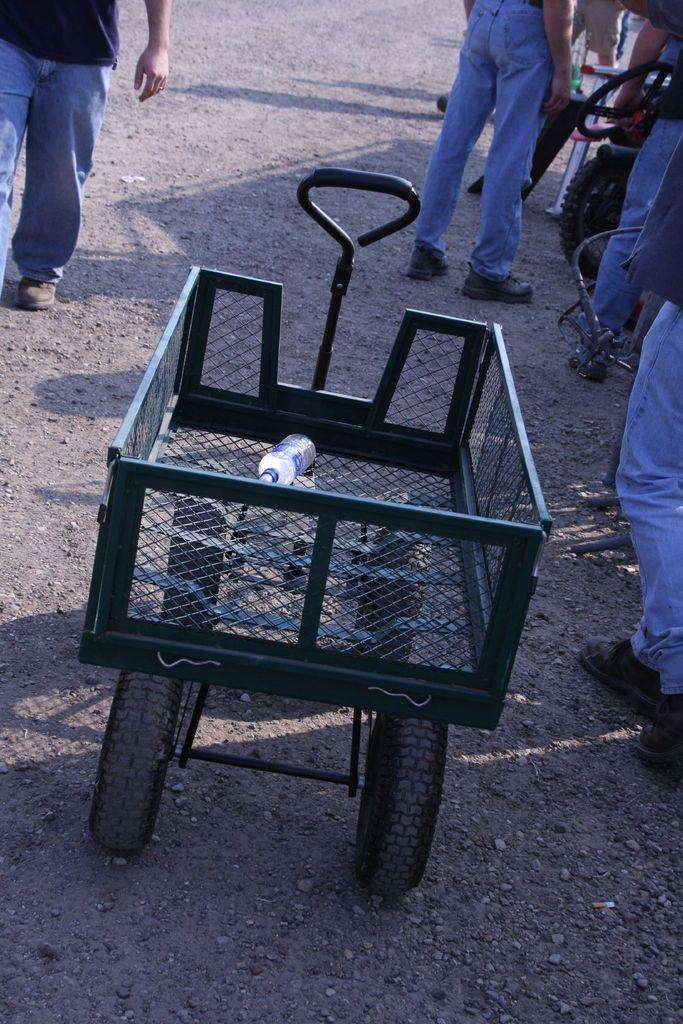What is the main object in the image? There is a cart in the image. What is inside the cart? There is a bottle in the cart. How many people can be seen in the image? There are many people in the image. What type of paste is being used by the people in the image? There is no paste visible or mentioned in the image; it only features a cart with a bottle and many people. 